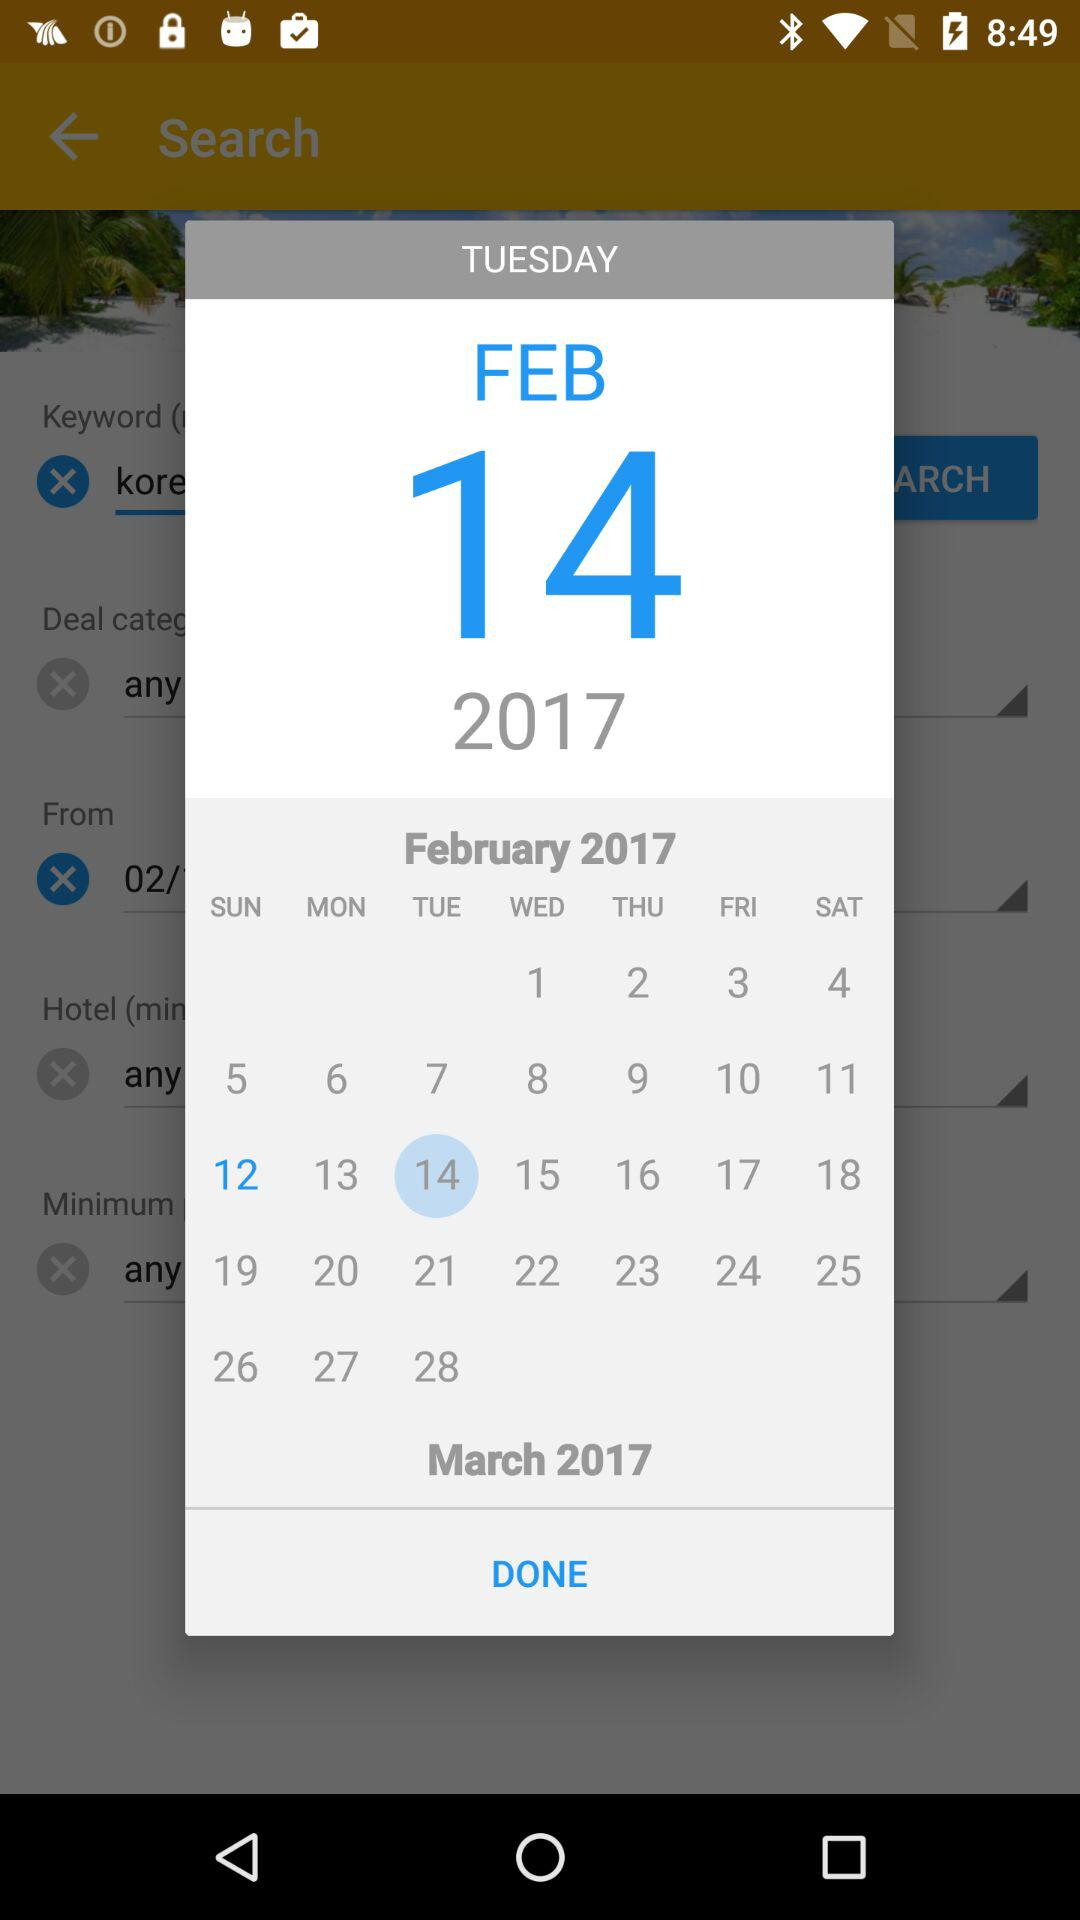Which date is selected? The selected date is Tuesday, February 14, 2017. 